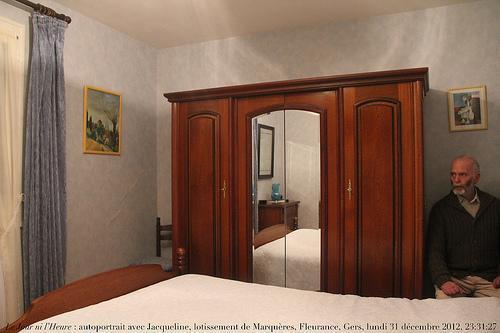How many people in the picture?
Give a very brief answer. 1. 